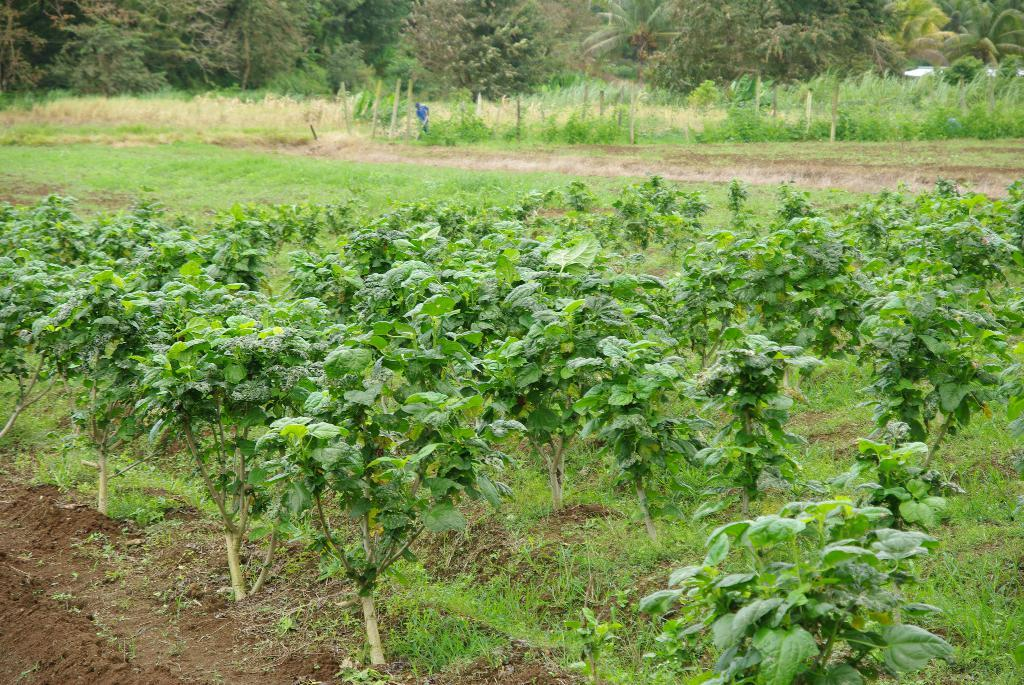What type of vegetation can be seen in the image? There are plants and trees visible in the image. What is the ground made of in the image? The grass is visible in the image. What structures can be seen in the image? There are poles in the image. What is the person in the image doing? A person is standing on the ground in the image. What else can be seen in the image besides the plants, grass, poles, and person? There are other objects present in the image. What type of medical assistance is the doctor providing during the earthquake in the image? There is no doctor or earthquake present in the image. What type of war is depicted in the image? There is no war depicted in the image. 